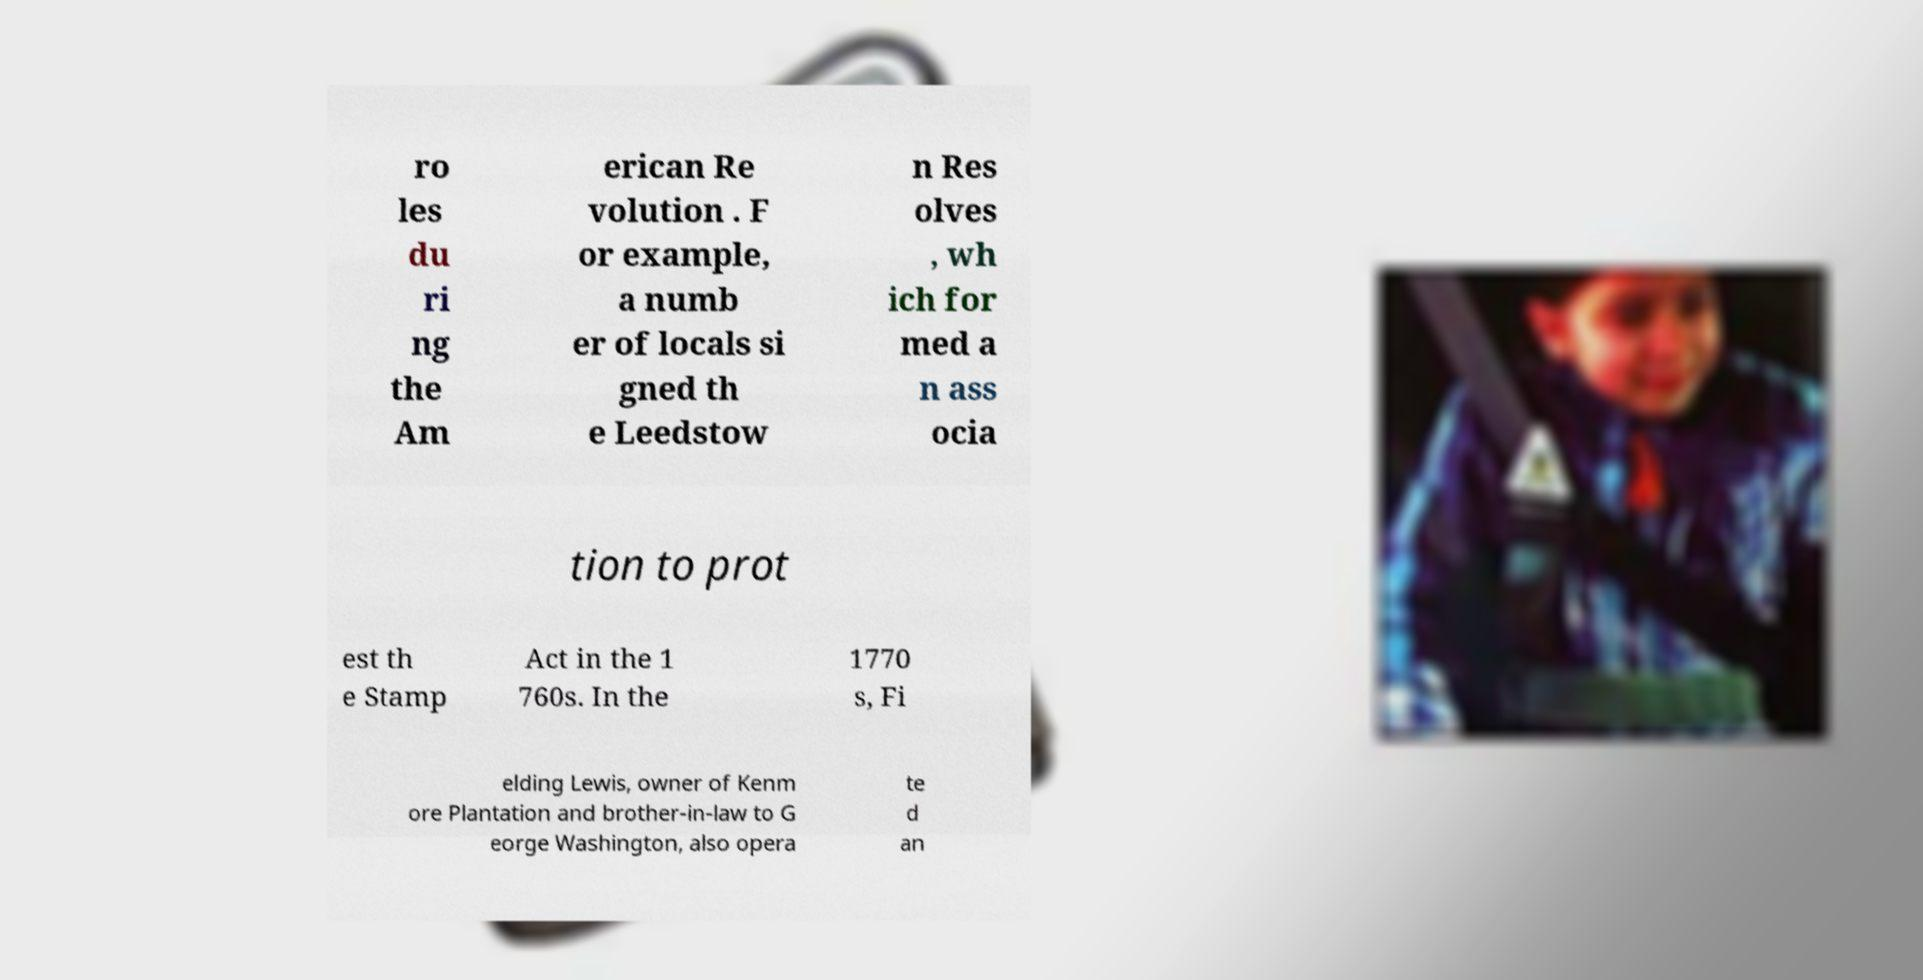For documentation purposes, I need the text within this image transcribed. Could you provide that? ro les du ri ng the Am erican Re volution . F or example, a numb er of locals si gned th e Leedstow n Res olves , wh ich for med a n ass ocia tion to prot est th e Stamp Act in the 1 760s. In the 1770 s, Fi elding Lewis, owner of Kenm ore Plantation and brother-in-law to G eorge Washington, also opera te d an 